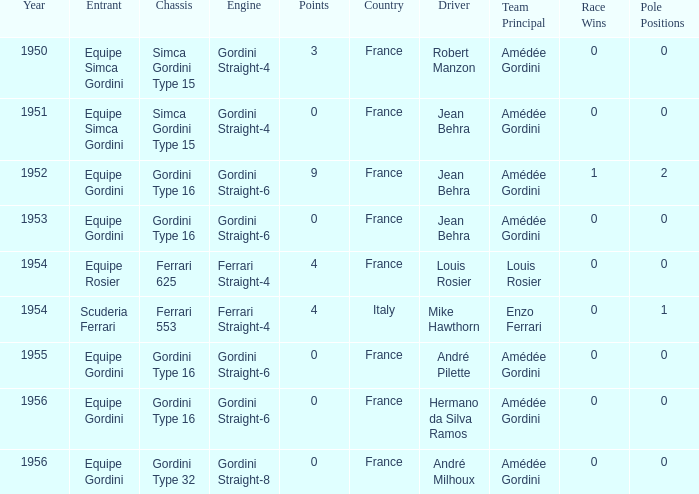Would you be able to parse every entry in this table? {'header': ['Year', 'Entrant', 'Chassis', 'Engine', 'Points', 'Country', 'Driver', 'Team Principal', 'Race Wins', 'Pole Positions '], 'rows': [['1950', 'Equipe Simca Gordini', 'Simca Gordini Type 15', 'Gordini Straight-4', '3', 'France', 'Robert Manzon', 'Amédée Gordini', '0', '0'], ['1951', 'Equipe Simca Gordini', 'Simca Gordini Type 15', 'Gordini Straight-4', '0', 'France', 'Jean Behra', 'Amédée Gordini', '0', '0'], ['1952', 'Equipe Gordini', 'Gordini Type 16', 'Gordini Straight-6', '9', 'France', 'Jean Behra', 'Amédée Gordini', '1', '2'], ['1953', 'Equipe Gordini', 'Gordini Type 16', 'Gordini Straight-6', '0', 'France', 'Jean Behra', 'Amédée Gordini', '0', '0'], ['1954', 'Equipe Rosier', 'Ferrari 625', 'Ferrari Straight-4', '4', 'France', 'Louis Rosier', 'Louis Rosier', '0', '0'], ['1954', 'Scuderia Ferrari', 'Ferrari 553', 'Ferrari Straight-4', '4', 'Italy', 'Mike Hawthorn', 'Enzo Ferrari', '0', '1'], ['1955', 'Equipe Gordini', 'Gordini Type 16', 'Gordini Straight-6', '0', 'France', 'André Pilette', 'Amédée Gordini', '0', '0'], ['1956', 'Equipe Gordini', 'Gordini Type 16', 'Gordini Straight-6', '0', 'France', 'Hermano da Silva Ramos', 'Amédée Gordini', '0', '0'], ['1956', 'Equipe Gordini', 'Gordini Type 32', 'Gordini Straight-8', '0', 'France', 'André Milhoux', 'Amédée Gordini', '0', '0']]} What chassis has smaller than 9 points by Equipe Rosier? Ferrari 625. 